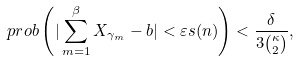<formula> <loc_0><loc_0><loc_500><loc_500>\ p r o b \left ( | \sum _ { m = 1 } ^ { \beta } X _ { \gamma _ { m } } - b | < \varepsilon s ( n ) \right ) < \frac { \delta } { 3 { \kappa \choose 2 } } ,</formula> 